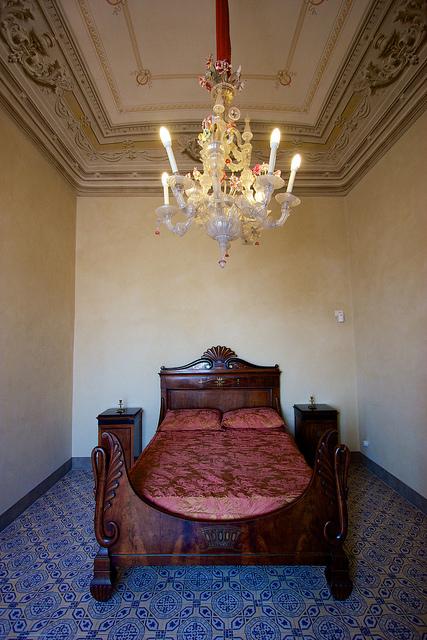What color is the bed?
Be succinct. Red. Is this an antique bed?
Concise answer only. Yes. What kind of furniture is this?
Quick response, please. Bed. What are the walls made out of?
Concise answer only. Plaster. Is this room large?
Short answer required. No. 